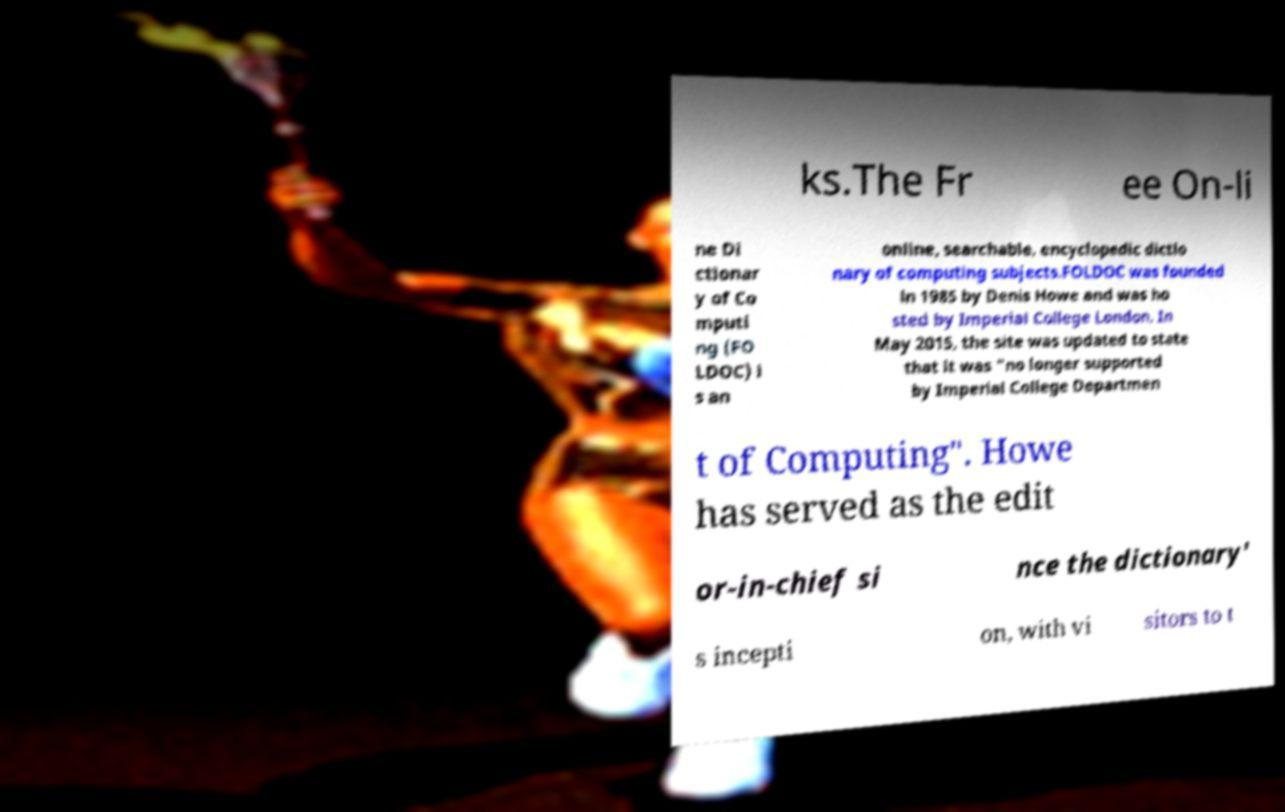For documentation purposes, I need the text within this image transcribed. Could you provide that? ks.The Fr ee On-li ne Di ctionar y of Co mputi ng (FO LDOC) i s an online, searchable, encyclopedic dictio nary of computing subjects.FOLDOC was founded in 1985 by Denis Howe and was ho sted by Imperial College London. In May 2015, the site was updated to state that it was "no longer supported by Imperial College Departmen t of Computing". Howe has served as the edit or-in-chief si nce the dictionary' s incepti on, with vi sitors to t 